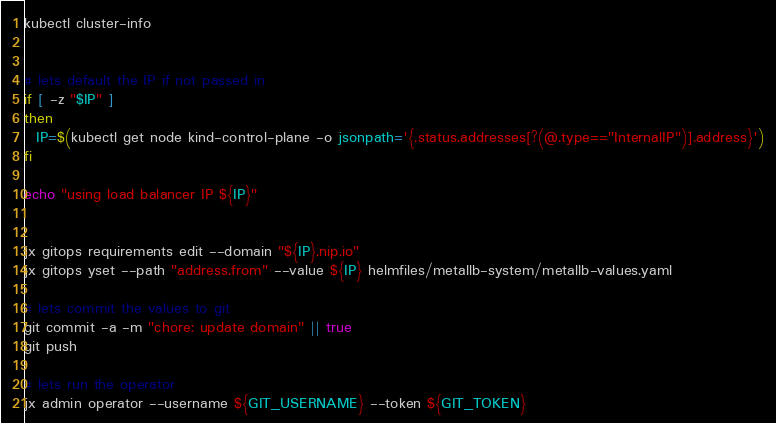<code> <loc_0><loc_0><loc_500><loc_500><_Bash_>kubectl cluster-info


# lets default the IP if not passed in
if [ -z "$IP" ]
then
  IP=$(kubectl get node kind-control-plane -o jsonpath='{.status.addresses[?(@.type=="InternalIP")].address}')
fi

echo "using load balancer IP ${IP}"


jx gitops requirements edit --domain "${IP}.nip.io"
jx gitops yset --path "address.from" --value ${IP} helmfiles/metallb-system/metallb-values.yaml

# lets commit the values to git
git commit -a -m "chore: update domain" || true
git push

# lets run the operator
jx admin operator --username ${GIT_USERNAME} --token ${GIT_TOKEN}
</code> 